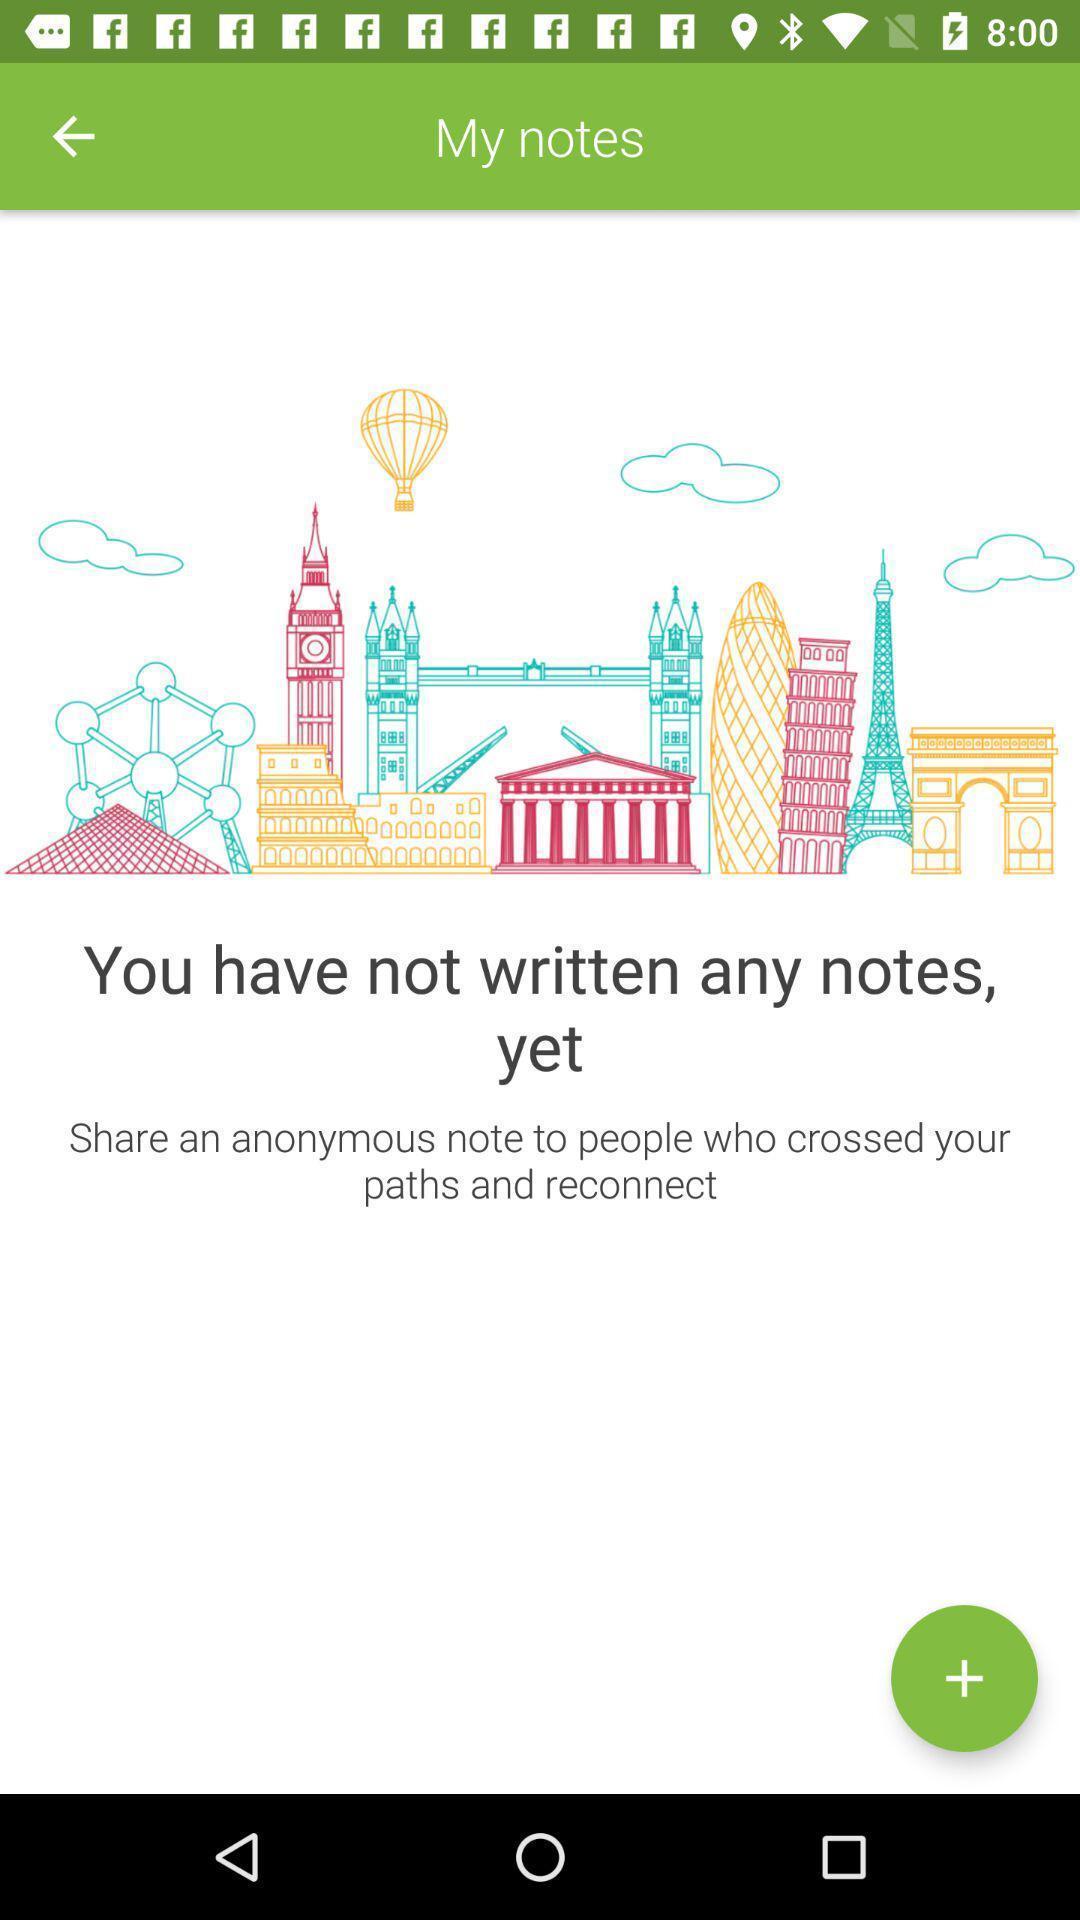Please provide a description for this image. Page displaying results for my notes. 